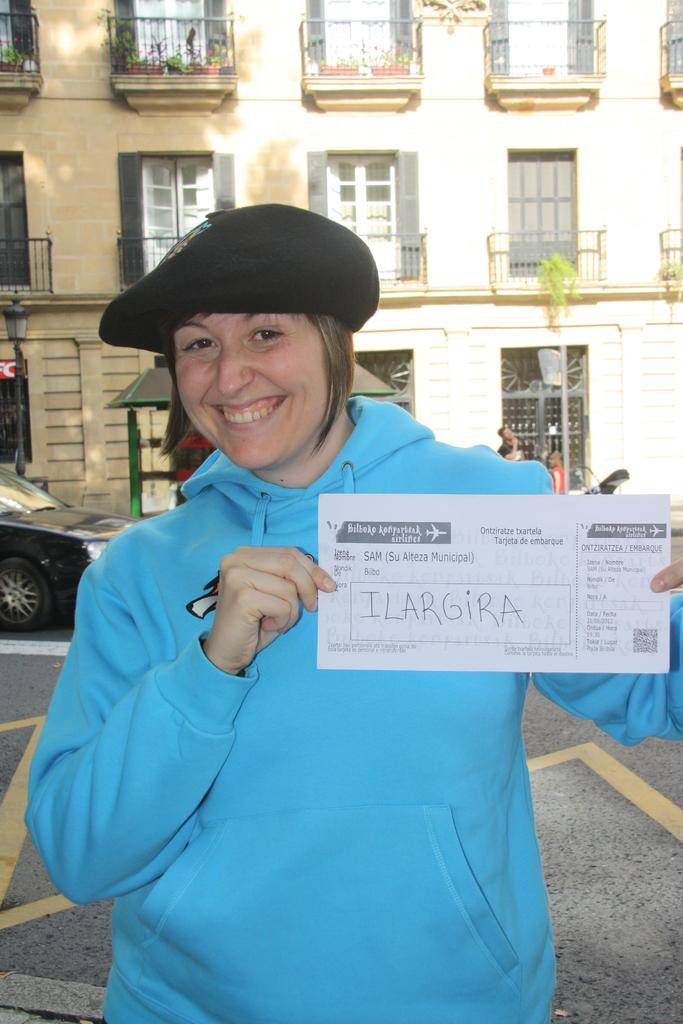What is the person in the image holding? The person is holding a paper. What is the person wearing on their head? The person is wearing a black cap. What color is the top the person is wearing? The person is wearing a blue top. What can be seen in the background of the image? There is a building with visible windows in the background. What other objects are present in the image? There is a light-pole and a vehicle on the road in the image. What type of argument is the person having with the scissors in the image? There are no scissors or arguments present in the image; the person is holding a paper and wearing a blue top and a black cap. 